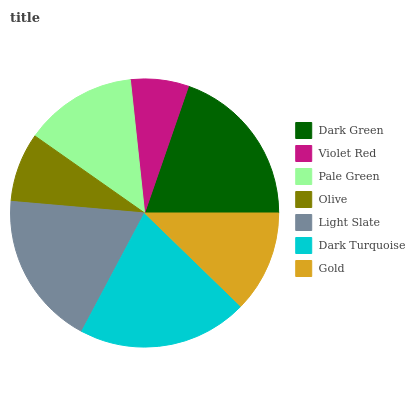Is Violet Red the minimum?
Answer yes or no. Yes. Is Dark Turquoise the maximum?
Answer yes or no. Yes. Is Pale Green the minimum?
Answer yes or no. No. Is Pale Green the maximum?
Answer yes or no. No. Is Pale Green greater than Violet Red?
Answer yes or no. Yes. Is Violet Red less than Pale Green?
Answer yes or no. Yes. Is Violet Red greater than Pale Green?
Answer yes or no. No. Is Pale Green less than Violet Red?
Answer yes or no. No. Is Pale Green the high median?
Answer yes or no. Yes. Is Pale Green the low median?
Answer yes or no. Yes. Is Gold the high median?
Answer yes or no. No. Is Violet Red the low median?
Answer yes or no. No. 